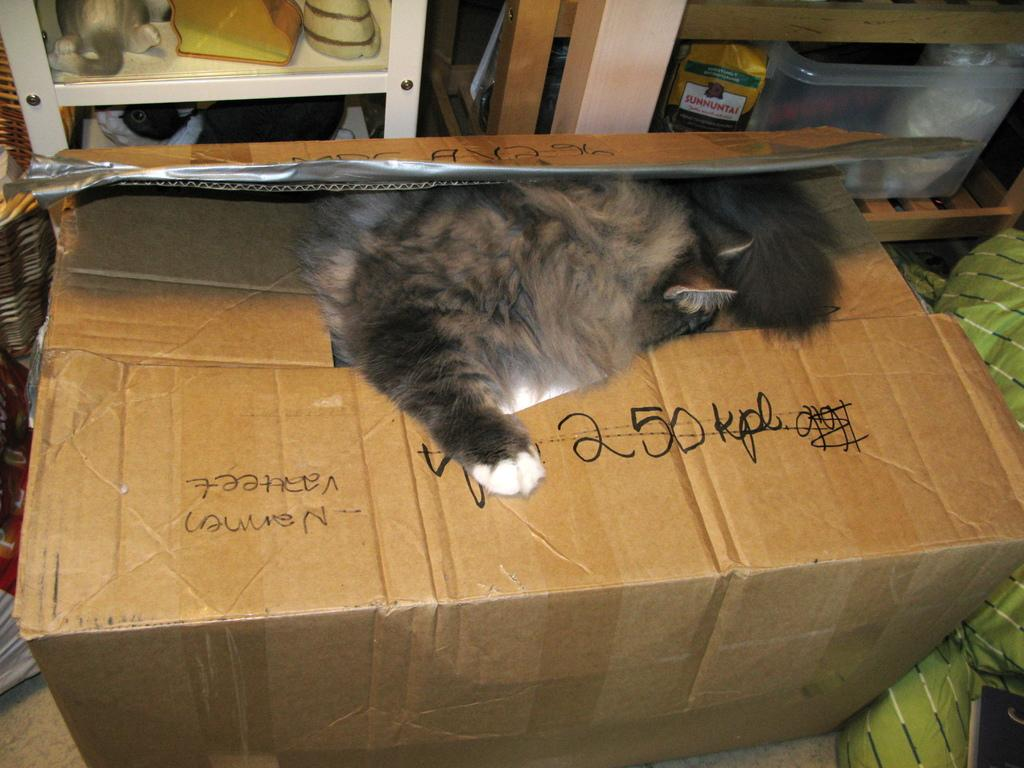<image>
Create a compact narrative representing the image presented. A cat is playing in a cardboard box with "250 kpl" written on it. 